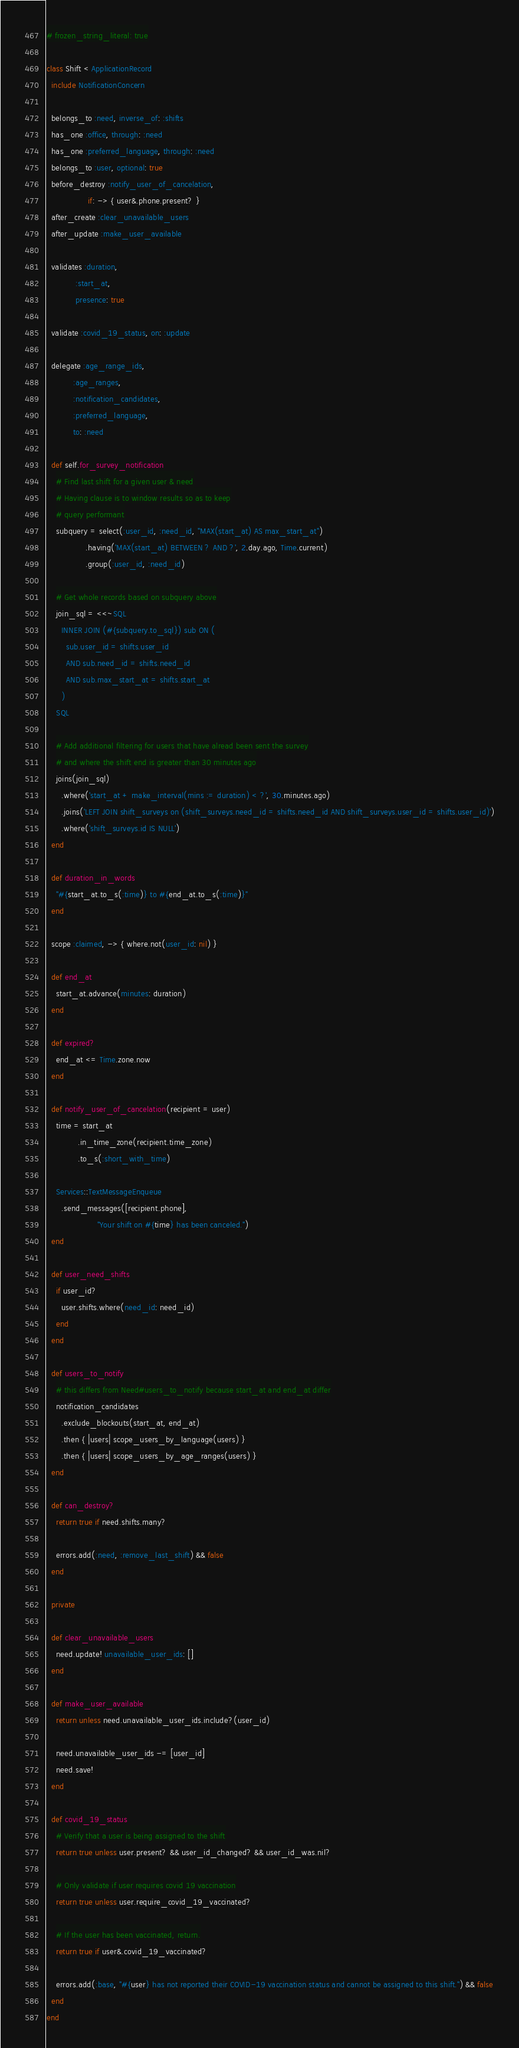<code> <loc_0><loc_0><loc_500><loc_500><_Ruby_># frozen_string_literal: true

class Shift < ApplicationRecord
  include NotificationConcern

  belongs_to :need, inverse_of: :shifts
  has_one :office, through: :need
  has_one :preferred_language, through: :need
  belongs_to :user, optional: true
  before_destroy :notify_user_of_cancelation,
                 if: -> { user&.phone.present? }
  after_create :clear_unavailable_users
  after_update :make_user_available

  validates :duration,
            :start_at,
            presence: true
  
  validate :covid_19_status, on: :update

  delegate :age_range_ids,
           :age_ranges,
           :notification_candidates,
           :preferred_language,
           to: :need

  def self.for_survey_notification
    # Find last shift for a given user & need
    # Having clause is to window results so as to keep
    # query performant
    subquery = select(:user_id, :need_id, "MAX(start_at) AS max_start_at")
                .having('MAX(start_at) BETWEEN ? AND ?', 2.day.ago, Time.current)
                .group(:user_id, :need_id)

    # Get whole records based on subquery above
    join_sql = <<~SQL
      INNER JOIN (#{subquery.to_sql}) sub ON (
        sub.user_id = shifts.user_id
        AND sub.need_id = shifts.need_id
        AND sub.max_start_at = shifts.start_at
      )
    SQL

    # Add additional filtering for users that have alread been sent the survey
    # and where the shift end is greater than 30 minutes ago
    joins(join_sql)
      .where('start_at + make_interval(mins := duration) < ?', 30.minutes.ago)
      .joins('LEFT JOIN shift_surveys on (shift_surveys.need_id = shifts.need_id AND shift_surveys.user_id = shifts.user_id)')
      .where('shift_surveys.id IS NULL')
  end

  def duration_in_words
    "#{start_at.to_s(:time)} to #{end_at.to_s(:time)}"
  end

  scope :claimed, -> { where.not(user_id: nil) }

  def end_at
    start_at.advance(minutes: duration)
  end

  def expired?
    end_at <= Time.zone.now
  end

  def notify_user_of_cancelation(recipient = user)
    time = start_at
             .in_time_zone(recipient.time_zone)
             .to_s(:short_with_time)

    Services::TextMessageEnqueue
      .send_messages([recipient.phone],
                     "Your shift on #{time} has been canceled.")
  end

  def user_need_shifts
    if user_id?
      user.shifts.where(need_id: need_id)
    end
  end

  def users_to_notify
    # this differs from Need#users_to_notify because start_at and end_at differ
    notification_candidates
      .exclude_blockouts(start_at, end_at)
      .then { |users| scope_users_by_language(users) }
      .then { |users| scope_users_by_age_ranges(users) }
  end

  def can_destroy?
    return true if need.shifts.many?

    errors.add(:need, :remove_last_shift) && false
  end

  private

  def clear_unavailable_users
    need.update! unavailable_user_ids: []
  end

  def make_user_available
    return unless need.unavailable_user_ids.include?(user_id)

    need.unavailable_user_ids -= [user_id]
    need.save!
  end

  def covid_19_status
    # Verify that a user is being assigned to the shift
    return true unless user.present? && user_id_changed? && user_id_was.nil?

    # Only validate if user requires covid 19 vaccination
    return true unless user.require_covid_19_vaccinated?

    # If the user has been vaccinated, return.
    return true if user&.covid_19_vaccinated?

    errors.add(:base, "#{user} has not reported their COVID-19 vaccination status and cannot be assigned to this shift.") && false
  end
end
</code> 